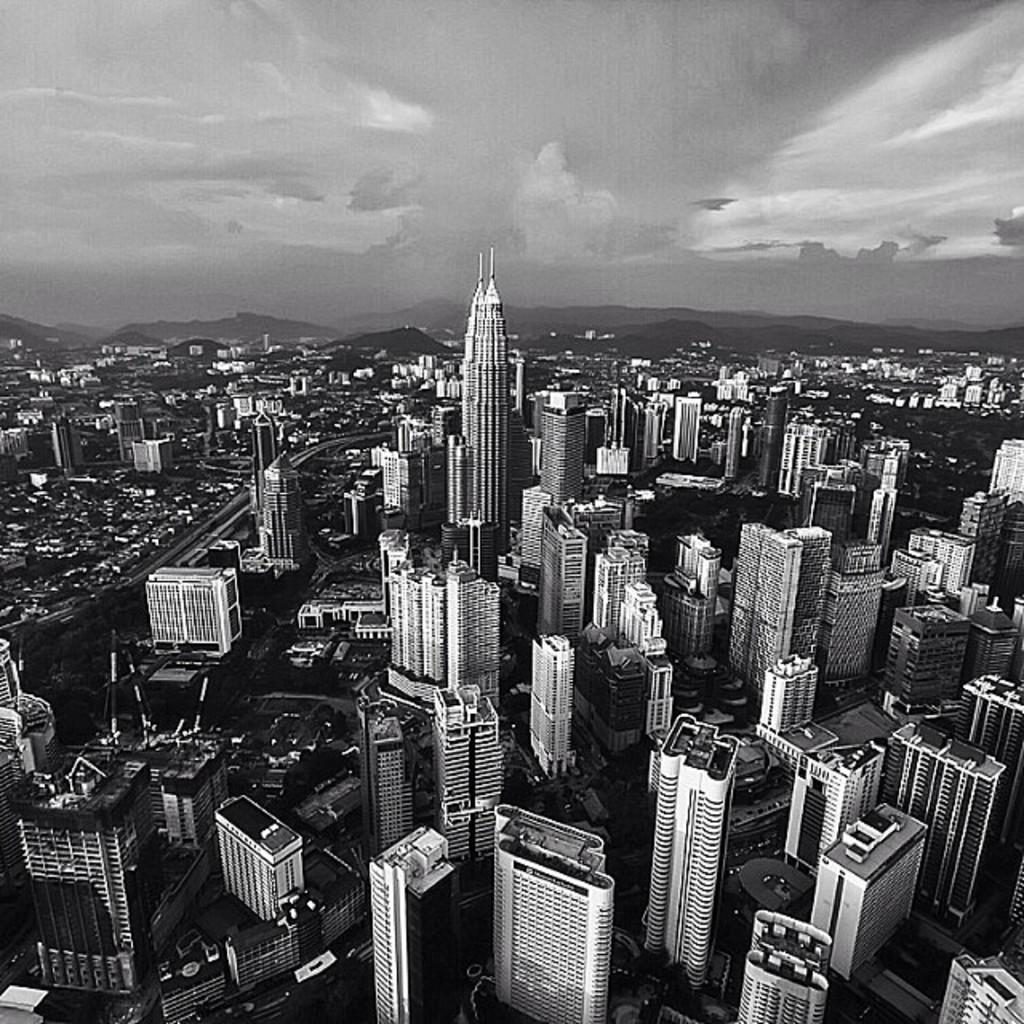What type of location is depicted in the image? The image depicts a city. What are some characteristics of the city? There are many tall buildings in the city, and there is a tall building visible in the image. What can be seen in the background of the image? Hills and the sky are visible in the background of the image. What is the condition of the sky in the image? Clouds are present in the sky. Reasoning: Let's think step by step by step in order to produce the conversation. We start by identifying the main subject of the image, which is a city. Then, we describe specific features of the city, such as the tall buildings. Next, we observe the background of the image, noting the presence of hills and the sky. Finally, we describe the sky's condition, which is cloudy. Absurd Question/Answer: How many horses can be seen working in the fields in the image? There are no horses or fields present in the image; it depicts a city with tall buildings and a cloudy sky. 